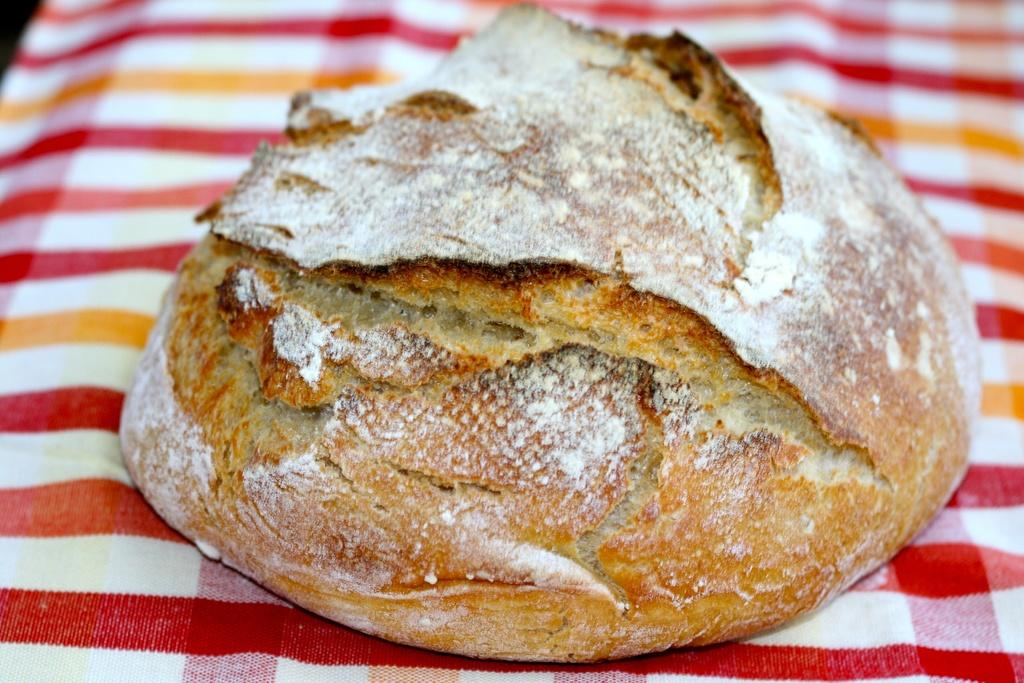What is the main subject of the image? There is a food item in the image. How is the food item presented? The food item is on a cloth. What additional detail can be observed on the food item? There is white powder on the food item. What type of advertisement is being displayed on the food item? There is no advertisement present on the food item in the image. 